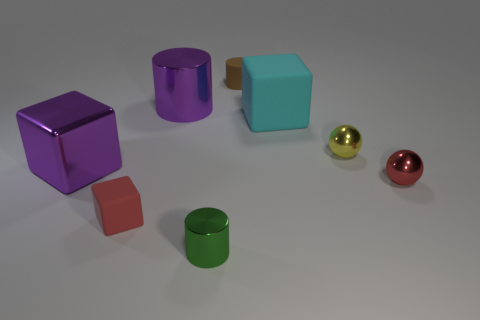Add 2 matte objects. How many objects exist? 10 Subtract all cubes. How many objects are left? 5 Subtract 1 green cylinders. How many objects are left? 7 Subtract all small blue metal cylinders. Subtract all red metallic balls. How many objects are left? 7 Add 7 metallic balls. How many metallic balls are left? 9 Add 1 small balls. How many small balls exist? 3 